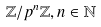<formula> <loc_0><loc_0><loc_500><loc_500>\mathbb { Z } / p ^ { n } \mathbb { Z } , n \in \mathbb { N }</formula> 